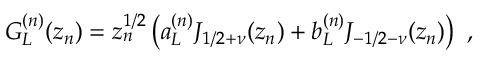Convert formula to latex. <formula><loc_0><loc_0><loc_500><loc_500>G _ { L } ^ { ( n ) } ( z _ { n } ) = z _ { n } ^ { 1 / 2 } \left ( a _ { L } ^ { ( n ) } J _ { 1 / 2 + \nu } ( z _ { n } ) + b _ { L } ^ { ( n ) } J _ { - 1 / 2 - \nu } ( z _ { n } ) \right ) ,</formula> 